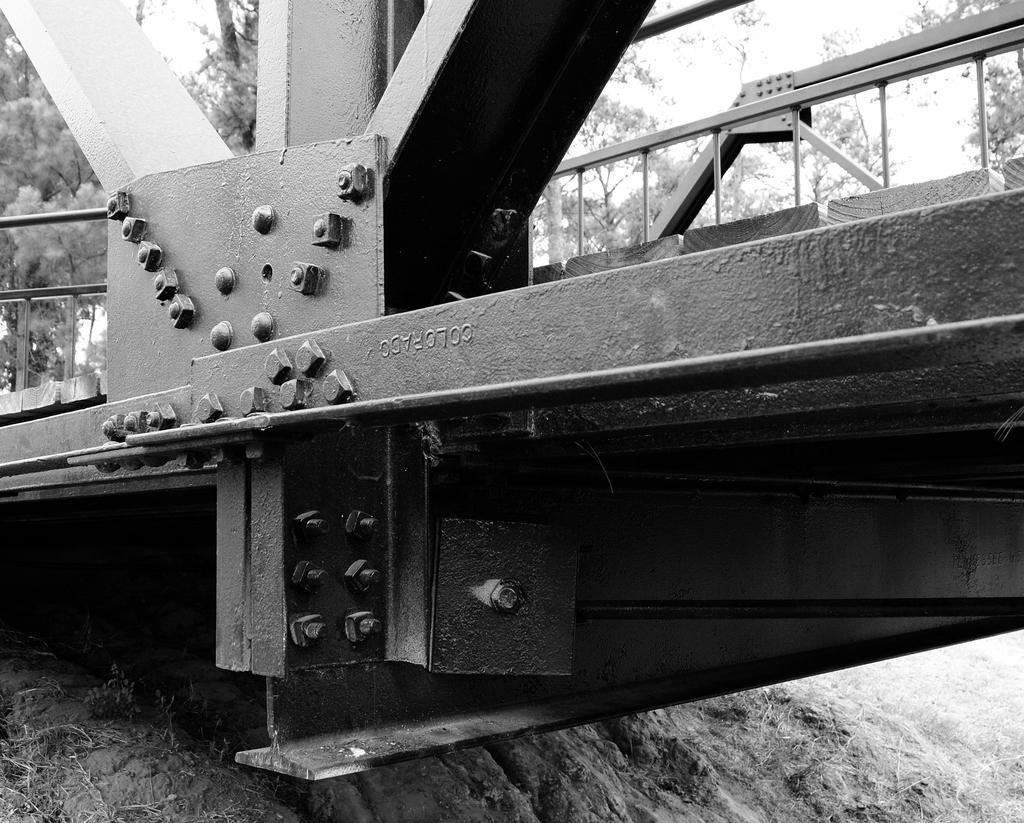What is the color scheme of the image? The image is black and white. What is the main subject of the image? The image appears to depict a bridge. What materials might have been used to construct the bridge? The presence of bolts suggests that iron bars were used in the construction of the bridge. What can be seen in the background of the image? There are trees in the background of the image. How many dogs are visible on the bridge in the image? There are no dogs present in the image; it depicts a bridge with no visible animals. Can you tell me which leg the basketball is on in the image? There is no basketball present in the image, so it is not possible to determine which leg it might be on. 